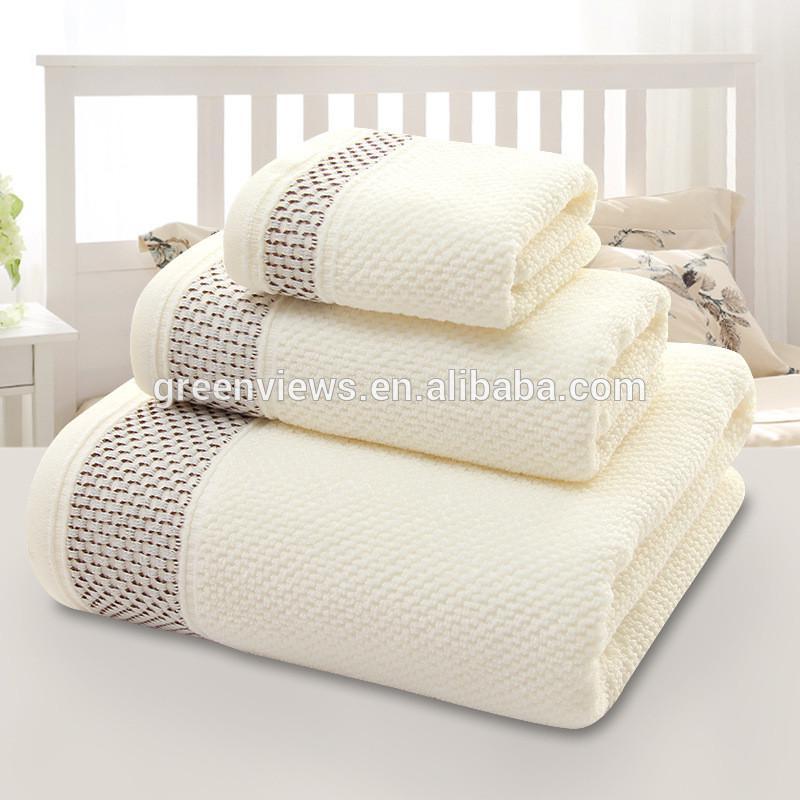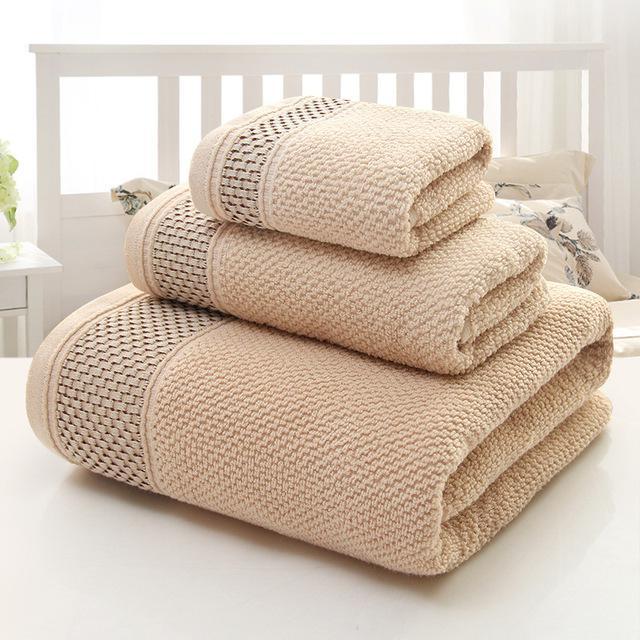The first image is the image on the left, the second image is the image on the right. Assess this claim about the two images: "There is exactly one yellow towel.". Correct or not? Answer yes or no. No. The first image is the image on the left, the second image is the image on the right. Evaluate the accuracy of this statement regarding the images: "There are exactly three folded towels in at least one image.". Is it true? Answer yes or no. Yes. 